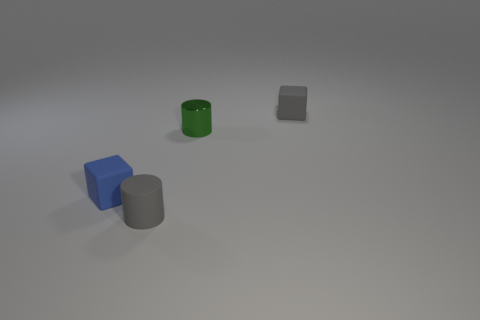What is the position of the blue cube in relation to the grey cylinder? The blue cube is positioned to the right of the grey cylinder when viewing the image. 
What is the lighting like in this scene? Does anything stand out about it? The lighting in the scene is soft and diffused, producing gentle shadows and a calm mood. There are no harsh highlights or deep shadows, indicating an ambient light source. 